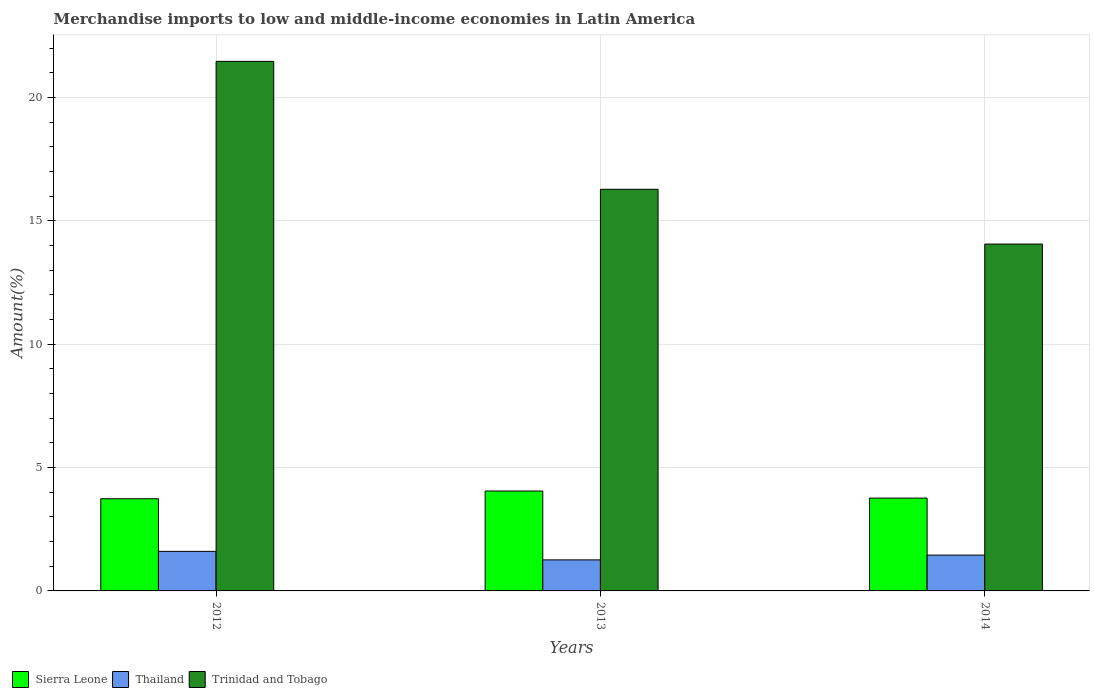Are the number of bars per tick equal to the number of legend labels?
Make the answer very short. Yes. Are the number of bars on each tick of the X-axis equal?
Offer a very short reply. Yes. In how many cases, is the number of bars for a given year not equal to the number of legend labels?
Keep it short and to the point. 0. What is the percentage of amount earned from merchandise imports in Sierra Leone in 2014?
Your response must be concise. 3.76. Across all years, what is the maximum percentage of amount earned from merchandise imports in Thailand?
Offer a very short reply. 1.6. Across all years, what is the minimum percentage of amount earned from merchandise imports in Trinidad and Tobago?
Your answer should be very brief. 14.06. In which year was the percentage of amount earned from merchandise imports in Trinidad and Tobago maximum?
Give a very brief answer. 2012. In which year was the percentage of amount earned from merchandise imports in Sierra Leone minimum?
Ensure brevity in your answer.  2012. What is the total percentage of amount earned from merchandise imports in Trinidad and Tobago in the graph?
Your answer should be compact. 51.81. What is the difference between the percentage of amount earned from merchandise imports in Trinidad and Tobago in 2012 and that in 2014?
Provide a succinct answer. 7.41. What is the difference between the percentage of amount earned from merchandise imports in Sierra Leone in 2014 and the percentage of amount earned from merchandise imports in Thailand in 2013?
Provide a succinct answer. 2.5. What is the average percentage of amount earned from merchandise imports in Sierra Leone per year?
Offer a terse response. 3.85. In the year 2013, what is the difference between the percentage of amount earned from merchandise imports in Trinidad and Tobago and percentage of amount earned from merchandise imports in Thailand?
Offer a very short reply. 15.02. In how many years, is the percentage of amount earned from merchandise imports in Trinidad and Tobago greater than 18 %?
Your answer should be compact. 1. What is the ratio of the percentage of amount earned from merchandise imports in Thailand in 2013 to that in 2014?
Offer a terse response. 0.87. Is the difference between the percentage of amount earned from merchandise imports in Trinidad and Tobago in 2012 and 2014 greater than the difference between the percentage of amount earned from merchandise imports in Thailand in 2012 and 2014?
Your answer should be compact. Yes. What is the difference between the highest and the second highest percentage of amount earned from merchandise imports in Thailand?
Your answer should be very brief. 0.15. What is the difference between the highest and the lowest percentage of amount earned from merchandise imports in Sierra Leone?
Provide a short and direct response. 0.31. In how many years, is the percentage of amount earned from merchandise imports in Thailand greater than the average percentage of amount earned from merchandise imports in Thailand taken over all years?
Offer a terse response. 2. Is the sum of the percentage of amount earned from merchandise imports in Trinidad and Tobago in 2012 and 2013 greater than the maximum percentage of amount earned from merchandise imports in Thailand across all years?
Provide a succinct answer. Yes. What does the 2nd bar from the left in 2012 represents?
Offer a terse response. Thailand. What does the 1st bar from the right in 2012 represents?
Your answer should be compact. Trinidad and Tobago. What is the difference between two consecutive major ticks on the Y-axis?
Provide a succinct answer. 5. Are the values on the major ticks of Y-axis written in scientific E-notation?
Offer a very short reply. No. Where does the legend appear in the graph?
Offer a very short reply. Bottom left. How many legend labels are there?
Provide a short and direct response. 3. How are the legend labels stacked?
Ensure brevity in your answer.  Horizontal. What is the title of the graph?
Your answer should be compact. Merchandise imports to low and middle-income economies in Latin America. What is the label or title of the Y-axis?
Provide a short and direct response. Amount(%). What is the Amount(%) in Sierra Leone in 2012?
Provide a short and direct response. 3.74. What is the Amount(%) in Thailand in 2012?
Provide a succinct answer. 1.6. What is the Amount(%) of Trinidad and Tobago in 2012?
Offer a terse response. 21.47. What is the Amount(%) in Sierra Leone in 2013?
Keep it short and to the point. 4.05. What is the Amount(%) of Thailand in 2013?
Provide a short and direct response. 1.26. What is the Amount(%) of Trinidad and Tobago in 2013?
Offer a terse response. 16.28. What is the Amount(%) in Sierra Leone in 2014?
Offer a very short reply. 3.76. What is the Amount(%) of Thailand in 2014?
Offer a terse response. 1.45. What is the Amount(%) in Trinidad and Tobago in 2014?
Keep it short and to the point. 14.06. Across all years, what is the maximum Amount(%) in Sierra Leone?
Provide a short and direct response. 4.05. Across all years, what is the maximum Amount(%) in Thailand?
Offer a terse response. 1.6. Across all years, what is the maximum Amount(%) in Trinidad and Tobago?
Make the answer very short. 21.47. Across all years, what is the minimum Amount(%) in Sierra Leone?
Keep it short and to the point. 3.74. Across all years, what is the minimum Amount(%) in Thailand?
Your response must be concise. 1.26. Across all years, what is the minimum Amount(%) of Trinidad and Tobago?
Your answer should be compact. 14.06. What is the total Amount(%) of Sierra Leone in the graph?
Your answer should be compact. 11.55. What is the total Amount(%) in Thailand in the graph?
Offer a terse response. 4.31. What is the total Amount(%) of Trinidad and Tobago in the graph?
Give a very brief answer. 51.81. What is the difference between the Amount(%) of Sierra Leone in 2012 and that in 2013?
Make the answer very short. -0.31. What is the difference between the Amount(%) in Thailand in 2012 and that in 2013?
Provide a short and direct response. 0.35. What is the difference between the Amount(%) in Trinidad and Tobago in 2012 and that in 2013?
Provide a succinct answer. 5.19. What is the difference between the Amount(%) in Sierra Leone in 2012 and that in 2014?
Your answer should be very brief. -0.03. What is the difference between the Amount(%) of Thailand in 2012 and that in 2014?
Offer a very short reply. 0.15. What is the difference between the Amount(%) in Trinidad and Tobago in 2012 and that in 2014?
Provide a short and direct response. 7.41. What is the difference between the Amount(%) of Sierra Leone in 2013 and that in 2014?
Your answer should be very brief. 0.29. What is the difference between the Amount(%) of Thailand in 2013 and that in 2014?
Keep it short and to the point. -0.19. What is the difference between the Amount(%) in Trinidad and Tobago in 2013 and that in 2014?
Your response must be concise. 2.22. What is the difference between the Amount(%) of Sierra Leone in 2012 and the Amount(%) of Thailand in 2013?
Provide a succinct answer. 2.48. What is the difference between the Amount(%) in Sierra Leone in 2012 and the Amount(%) in Trinidad and Tobago in 2013?
Keep it short and to the point. -12.55. What is the difference between the Amount(%) of Thailand in 2012 and the Amount(%) of Trinidad and Tobago in 2013?
Provide a short and direct response. -14.68. What is the difference between the Amount(%) in Sierra Leone in 2012 and the Amount(%) in Thailand in 2014?
Offer a terse response. 2.28. What is the difference between the Amount(%) in Sierra Leone in 2012 and the Amount(%) in Trinidad and Tobago in 2014?
Your response must be concise. -10.32. What is the difference between the Amount(%) of Thailand in 2012 and the Amount(%) of Trinidad and Tobago in 2014?
Your response must be concise. -12.46. What is the difference between the Amount(%) of Sierra Leone in 2013 and the Amount(%) of Thailand in 2014?
Ensure brevity in your answer.  2.6. What is the difference between the Amount(%) in Sierra Leone in 2013 and the Amount(%) in Trinidad and Tobago in 2014?
Keep it short and to the point. -10.01. What is the difference between the Amount(%) in Thailand in 2013 and the Amount(%) in Trinidad and Tobago in 2014?
Ensure brevity in your answer.  -12.8. What is the average Amount(%) of Sierra Leone per year?
Give a very brief answer. 3.85. What is the average Amount(%) in Thailand per year?
Offer a very short reply. 1.44. What is the average Amount(%) of Trinidad and Tobago per year?
Give a very brief answer. 17.27. In the year 2012, what is the difference between the Amount(%) of Sierra Leone and Amount(%) of Thailand?
Your answer should be very brief. 2.13. In the year 2012, what is the difference between the Amount(%) in Sierra Leone and Amount(%) in Trinidad and Tobago?
Ensure brevity in your answer.  -17.73. In the year 2012, what is the difference between the Amount(%) in Thailand and Amount(%) in Trinidad and Tobago?
Your answer should be compact. -19.86. In the year 2013, what is the difference between the Amount(%) in Sierra Leone and Amount(%) in Thailand?
Your response must be concise. 2.79. In the year 2013, what is the difference between the Amount(%) of Sierra Leone and Amount(%) of Trinidad and Tobago?
Give a very brief answer. -12.23. In the year 2013, what is the difference between the Amount(%) of Thailand and Amount(%) of Trinidad and Tobago?
Your response must be concise. -15.02. In the year 2014, what is the difference between the Amount(%) in Sierra Leone and Amount(%) in Thailand?
Give a very brief answer. 2.31. In the year 2014, what is the difference between the Amount(%) in Sierra Leone and Amount(%) in Trinidad and Tobago?
Make the answer very short. -10.3. In the year 2014, what is the difference between the Amount(%) in Thailand and Amount(%) in Trinidad and Tobago?
Make the answer very short. -12.61. What is the ratio of the Amount(%) of Sierra Leone in 2012 to that in 2013?
Your answer should be compact. 0.92. What is the ratio of the Amount(%) of Thailand in 2012 to that in 2013?
Your answer should be very brief. 1.27. What is the ratio of the Amount(%) of Trinidad and Tobago in 2012 to that in 2013?
Ensure brevity in your answer.  1.32. What is the ratio of the Amount(%) of Sierra Leone in 2012 to that in 2014?
Your response must be concise. 0.99. What is the ratio of the Amount(%) in Thailand in 2012 to that in 2014?
Make the answer very short. 1.1. What is the ratio of the Amount(%) in Trinidad and Tobago in 2012 to that in 2014?
Provide a succinct answer. 1.53. What is the ratio of the Amount(%) in Sierra Leone in 2013 to that in 2014?
Your answer should be very brief. 1.08. What is the ratio of the Amount(%) of Thailand in 2013 to that in 2014?
Offer a terse response. 0.87. What is the ratio of the Amount(%) in Trinidad and Tobago in 2013 to that in 2014?
Ensure brevity in your answer.  1.16. What is the difference between the highest and the second highest Amount(%) in Sierra Leone?
Provide a succinct answer. 0.29. What is the difference between the highest and the second highest Amount(%) of Thailand?
Ensure brevity in your answer.  0.15. What is the difference between the highest and the second highest Amount(%) of Trinidad and Tobago?
Your answer should be very brief. 5.19. What is the difference between the highest and the lowest Amount(%) of Sierra Leone?
Offer a very short reply. 0.31. What is the difference between the highest and the lowest Amount(%) in Thailand?
Your answer should be compact. 0.35. What is the difference between the highest and the lowest Amount(%) of Trinidad and Tobago?
Your answer should be very brief. 7.41. 